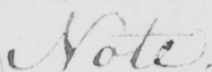Can you tell me what this handwritten text says? Note . 